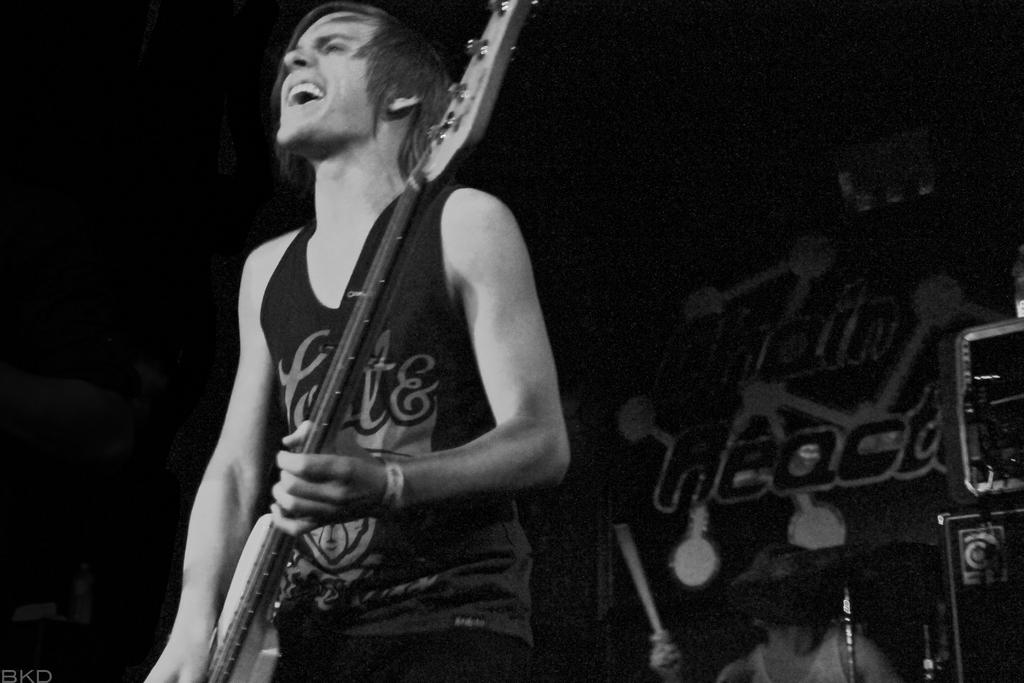What is the person in the image doing? The person is standing and holding a guitar. What might the person be doing while holding the guitar? The person's mouth is open, suggesting they are singing. What else can be seen in the image related to music? There are musical instruments visible in the background. What is the person's level of anger in the image? There is no indication of the person's level of anger in the image. 